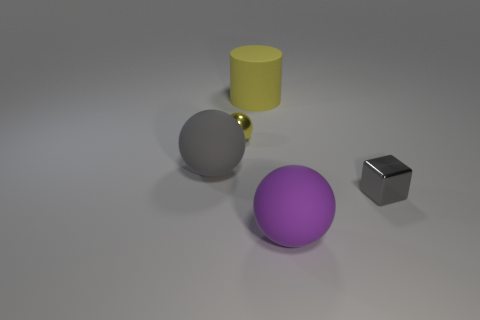What shape is the small shiny thing that is in front of the large gray matte object behind the large purple matte sphere?
Make the answer very short. Cube. What number of things are small metal objects that are behind the small block or matte things that are behind the large purple thing?
Your answer should be very brief. 3. There is a purple object that is made of the same material as the big gray object; what shape is it?
Your response must be concise. Sphere. Is there any other thing of the same color as the big cylinder?
Offer a terse response. Yes. There is a small object that is the same shape as the big gray thing; what material is it?
Provide a succinct answer. Metal. How many other objects are the same size as the yellow matte cylinder?
Your answer should be compact. 2. What material is the large yellow cylinder?
Your answer should be compact. Rubber. Are there more gray things that are left of the yellow shiny object than tiny yellow objects?
Keep it short and to the point. No. Are there any small purple shiny objects?
Give a very brief answer. No. What number of other things are there of the same shape as the gray metallic thing?
Ensure brevity in your answer.  0. 